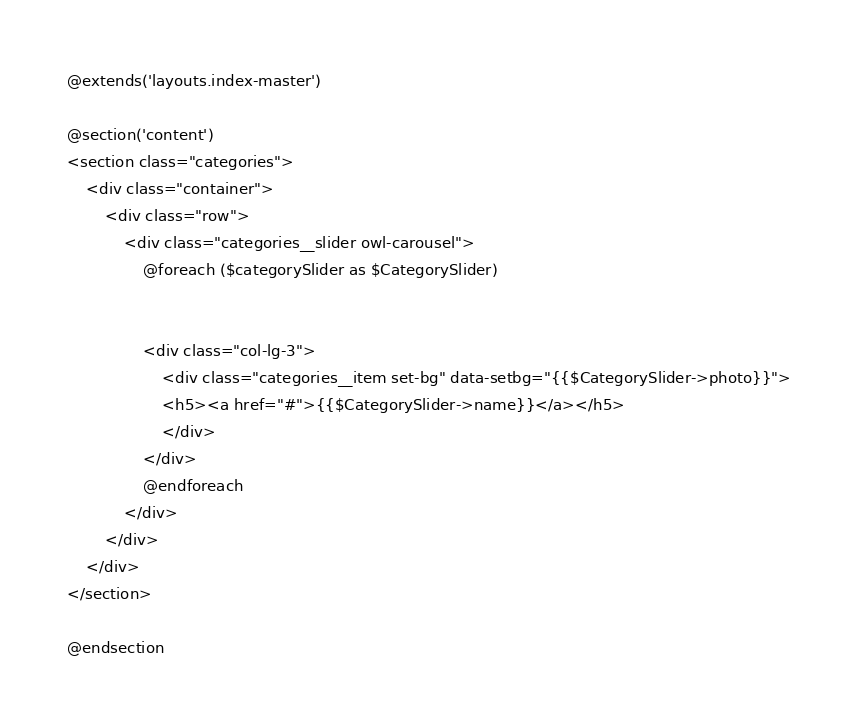Convert code to text. <code><loc_0><loc_0><loc_500><loc_500><_PHP_>@extends('layouts.index-master')

@section('content')
<section class="categories">
    <div class="container">
        <div class="row">
            <div class="categories__slider owl-carousel">
                @foreach ($categorySlider as $CategorySlider)


                <div class="col-lg-3">
                    <div class="categories__item set-bg" data-setbg="{{$CategorySlider->photo}}">
                    <h5><a href="#">{{$CategorySlider->name}}</a></h5>
                    </div>
                </div>
                @endforeach
            </div>
        </div>
    </div>
</section>

@endsection
</code> 